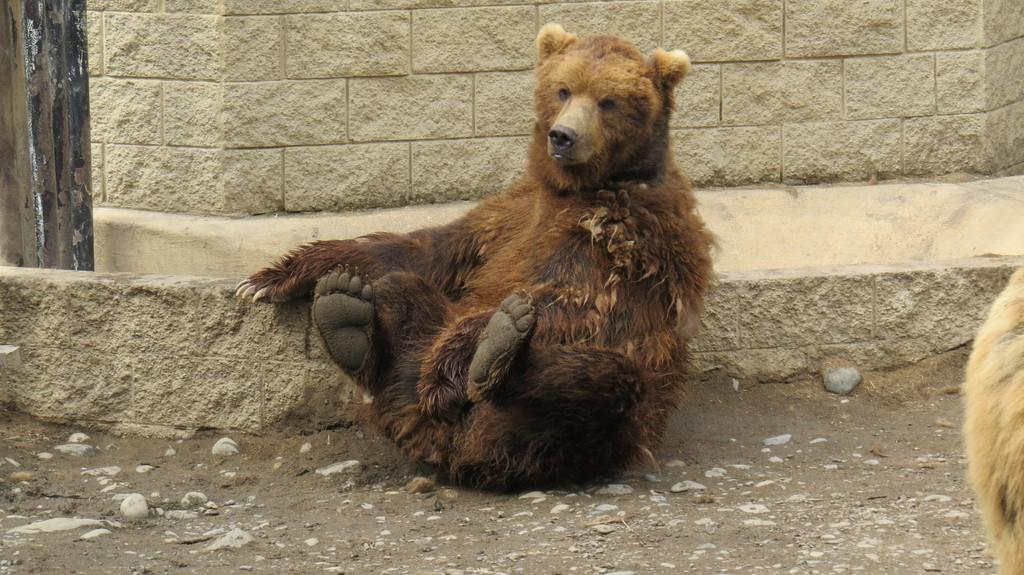What animal is sitting on the ground in the image? There is a bear sitting on the ground in the image. What can be seen at the bottom of the image? There are stones at the bottom of the image. What is visible in the background of the image? There is a wall in the background of the image. Are there any other bears in the image? Yes, there is another bear on the right side of the image. What page of the book does the bear turn to in the image? There is no book or page turning in the image; it features two bears sitting on the ground. 